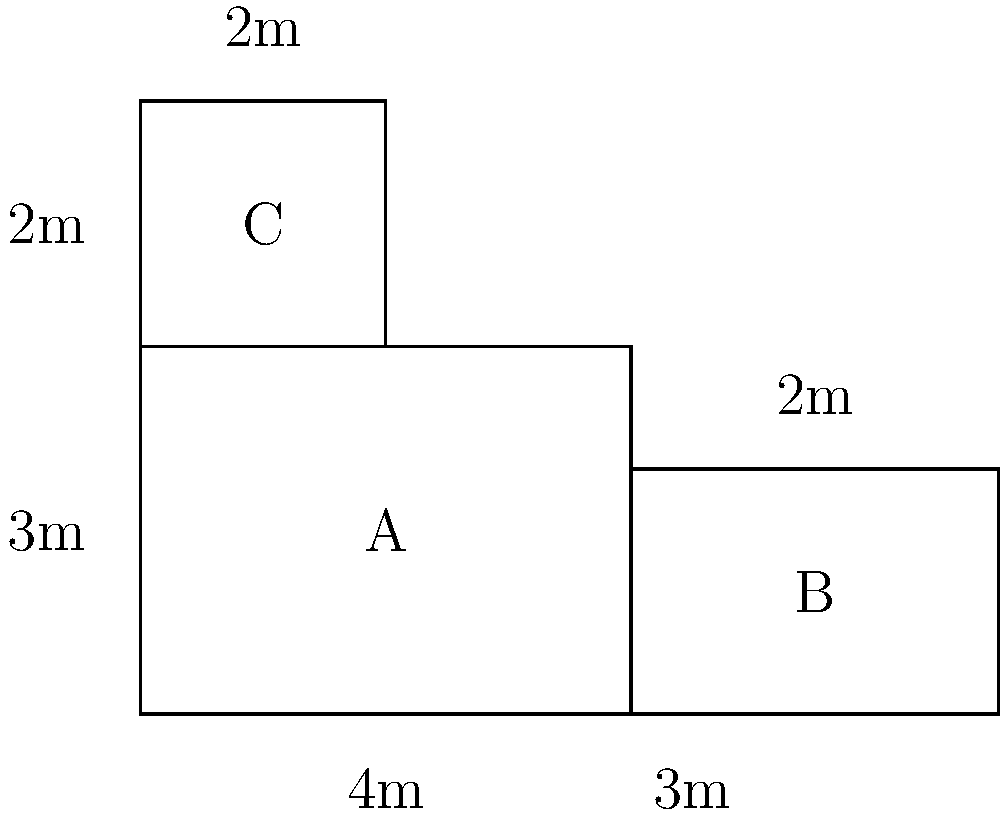You're planning a unique vegetable patch for your school garden. The patch is made up of three connected rectangular sections as shown in the diagram. Calculate the perimeter of this irregular-shaped vegetable patch. How can you use this problem to teach students about perimeter and real-world applications? To calculate the perimeter of this irregular-shaped vegetable patch, we need to add up all the outer edges. Let's break it down step-by-step:

1) First, let's identify the outer edges:
   - Bottom edge: $4 + 3 = 7$ m
   - Right edge: $2 + 2 = 4$ m
   - Top edge: $2 + 2 = 4$ m
   - Left edge: $3 + 2 = 5$ m

2) Now, let's add all these edges together:
   $7 + 4 + 4 + 5 = 20$ m

Therefore, the perimeter of the vegetable patch is 20 meters.

This problem can be used to teach students about perimeter and real-world applications in several ways:

1) It demonstrates that perimeter is the distance around the outside of a shape, even when the shape is irregular.

2) It shows how to break down complex shapes into simpler components (rectangles in this case).

3) It provides a practical application of math in gardening and landscaping.

4) Students can be encouraged to design their own vegetable patch shapes and calculate the perimeters, promoting creativity and applied math skills.

5) This can lead to discussions about efficient use of space in gardening, fencing requirements, and even introduce the concept of area for more advanced students.
Answer: 20 meters 